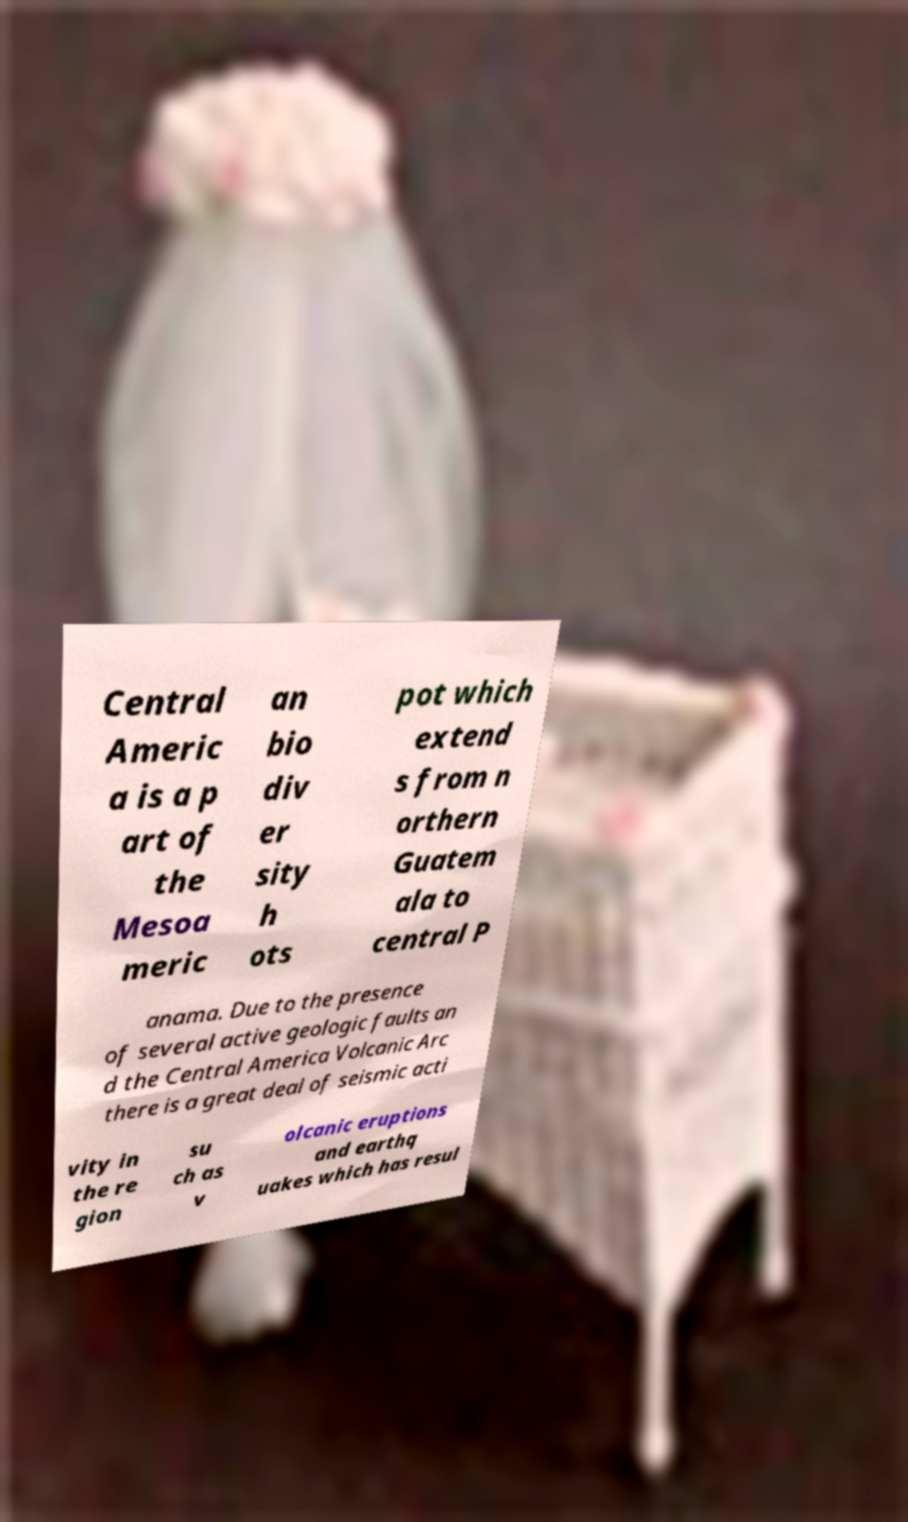Can you read and provide the text displayed in the image?This photo seems to have some interesting text. Can you extract and type it out for me? Central Americ a is a p art of the Mesoa meric an bio div er sity h ots pot which extend s from n orthern Guatem ala to central P anama. Due to the presence of several active geologic faults an d the Central America Volcanic Arc there is a great deal of seismic acti vity in the re gion su ch as v olcanic eruptions and earthq uakes which has resul 